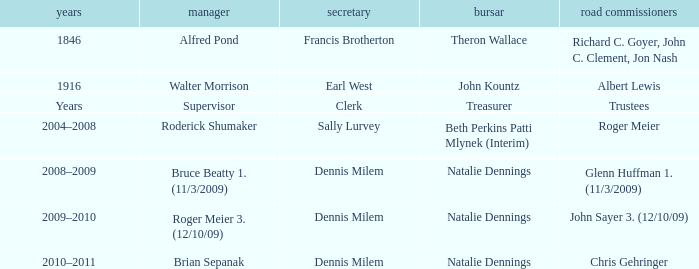Who was the clerk when the highway commissioner was Albert Lewis? Earl West. 